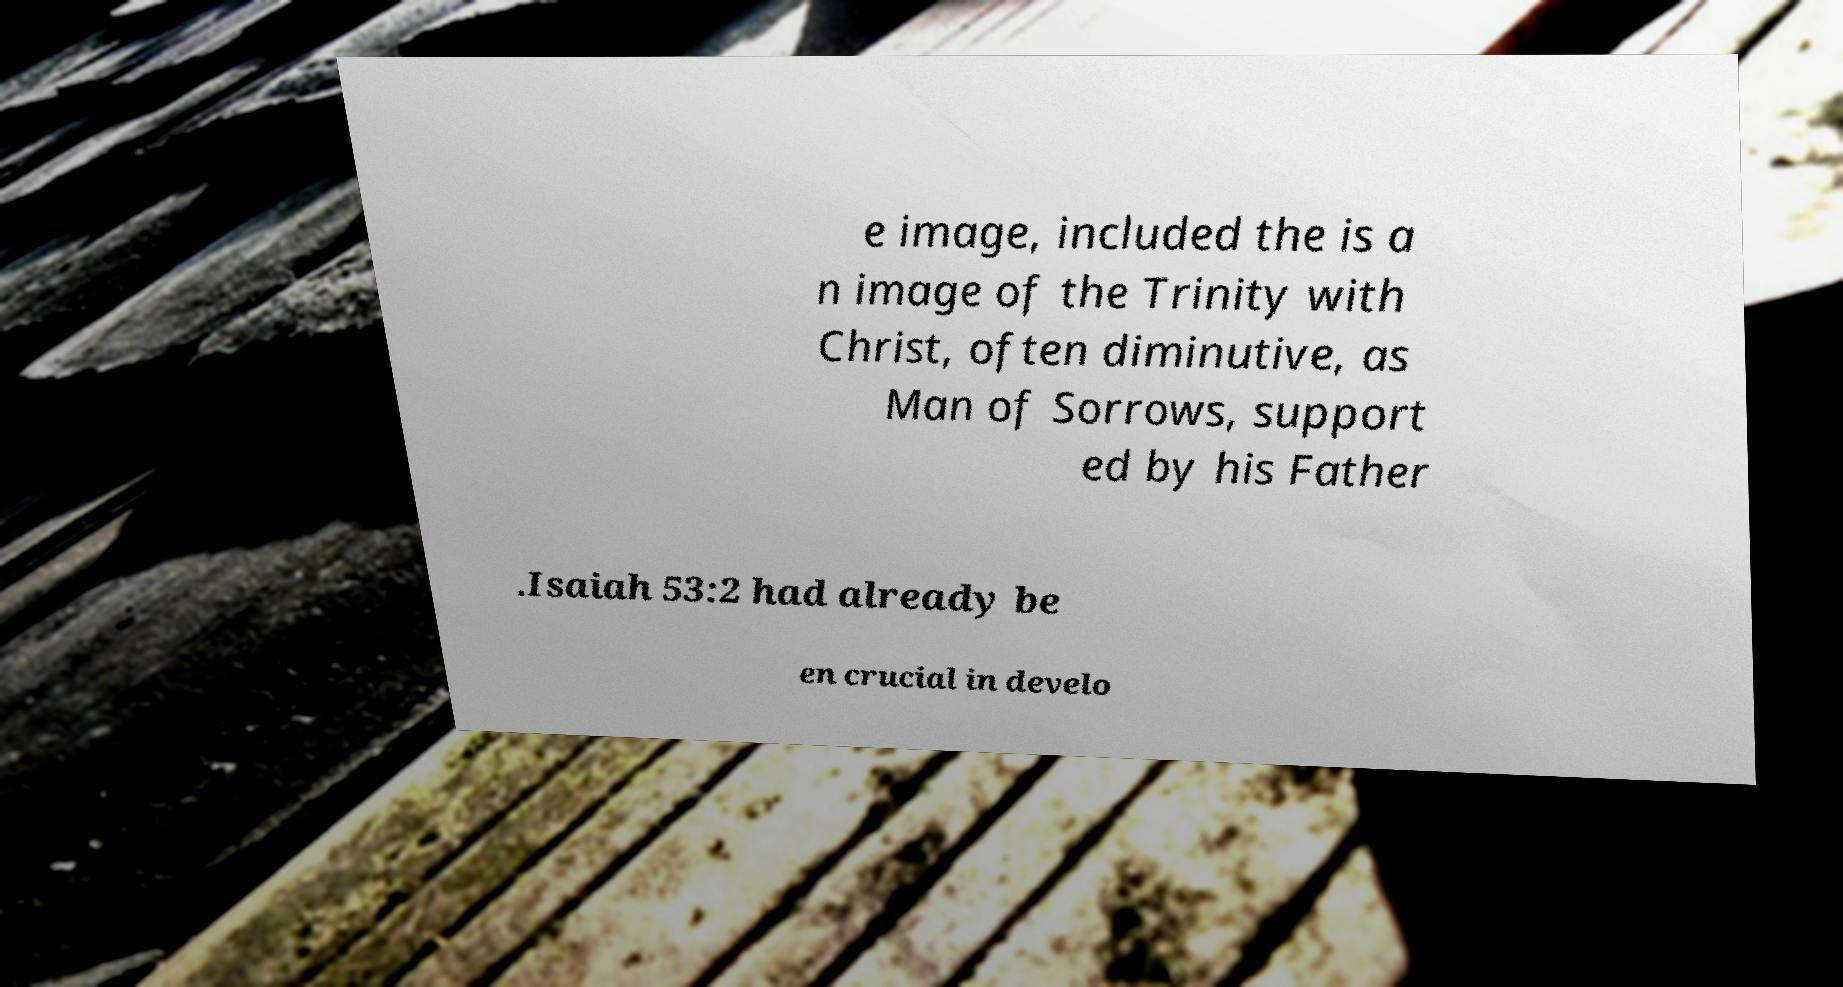I need the written content from this picture converted into text. Can you do that? e image, included the is a n image of the Trinity with Christ, often diminutive, as Man of Sorrows, support ed by his Father .Isaiah 53:2 had already be en crucial in develo 